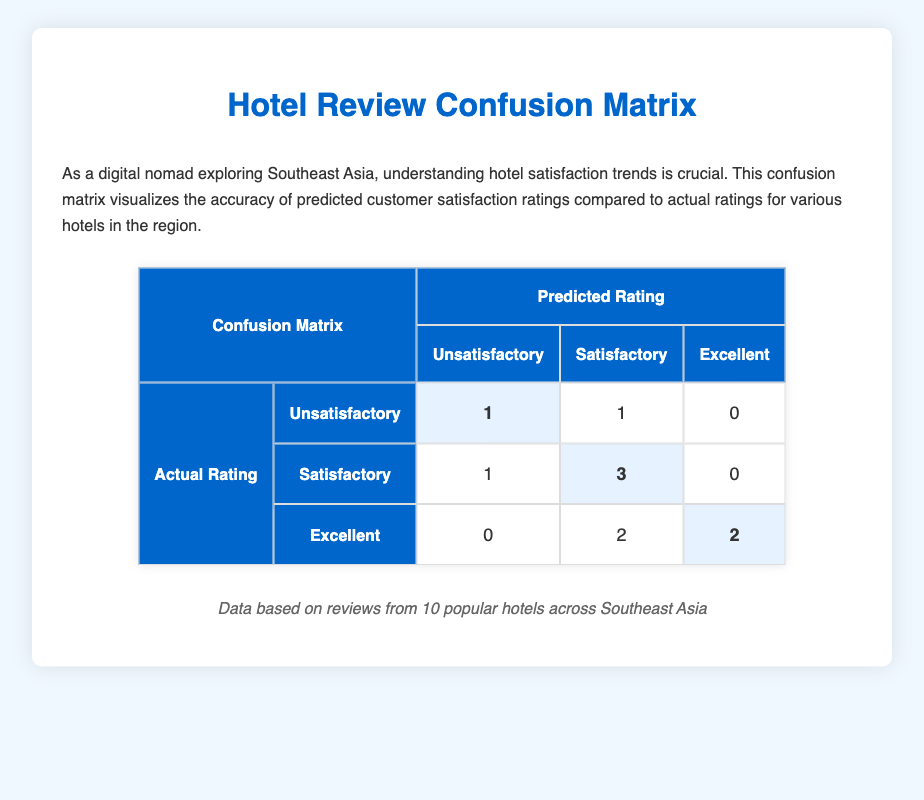What is the total number of hotels rated as 'Unsatisfactory'? According to the table, there is 1 hotel with an actual rating of 'Unsatisfactory' that also predicted as 'Unsatisfactory' and 1 hotel rated 'Satisfactory' that was predicted as 'Unsatisfactory'. Therefore, the total number is 1 + 1 = 2.
Answer: 2 How many hotels received an 'Excellent' actual rating but were predicted as 'Satisfactory'? The table shows that there are 2 hotels with 'Excellent' actual ratings that were predicted as 'Satisfactory', specifically "Banyan Tree Phuket" and "Raffles Hotel Singapore".
Answer: 2 What is the count of hotels that were correctly classified as 'Satisfactory'? The confusion matrix reveals 3 hotels that had both actual and predicted ratings as 'Satisfactory'. They are "The Majestic Hotel Kuala Lumpur", "InterContinental Danang Sun Peninsula Resort", and "Pullman Bangkok King Power".
Answer: 3 Is it true that there are no hotels that were rated 'Excellent' but predicted to be 'Unsatisfactory'? By looking at the confusion matrix, there are indeed 0 hotels rated 'Excellent' with a predicted rating of 'Unsatisfactory'. Thus, the statement is true.
Answer: Yes What is the total number of hotels that were classified as 'Excellent'? To find this, we can add the hotels rated as 'Excellent' in the confusion matrix. There are 2 hotels that had actual ratings of 'Excellent' that were predicted correctly as 'Excellent' and 2 hotels that had actual ratings of 'Satisfactory', but none rated as 'Unsatisfactory'. This leads to a total of 2 'Excellent' hotels classified in the confusion matrix.
Answer: 4 What percentage of hotels were predicted correctly compared to the total number of hotels? The total number of hotels is 10, and the correctly predicted hotels combine 'Satisfactory', 'Satisfactory', and 'Excellent' ratings: total correct predictions = 3 (Satisfactory) + 2 (Excellent) + 1 (Unsatisfactory) = 6. To find the percentage, calculate (6/10) * 100 = 60%.
Answer: 60% How many more hotels were predicted incorrectly as 'Unsatisfactory' rather than 'Excellent'? From the confusion matrix, it shows 3 hotels were incorrectly classified ('Unsatisfactory' predicted from 'Satisfactory' and 'Excellent'), whereas only 0 were incorrectly classified as 'Excellent'. Hence, the difference is 3 - 0 = 3.
Answer: 3 What is the maximum number of hotels predicted as 'Satisfactory'? The confusion matrix indicates there are 3 hotels with actual ratings that were also predicted as 'Satisfactory' (in addition to 1 from the 'Unsatisfactory' rating). So, the maximum number of hotels predicted as 'Satisfactory' is 3 from the matching column.
Answer: 5 